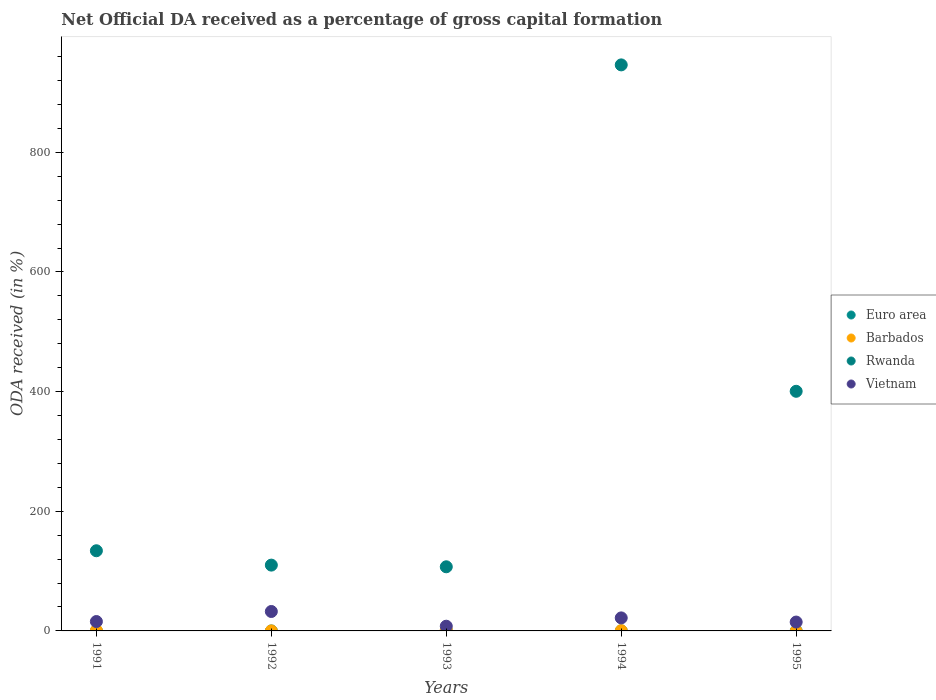Is the number of dotlines equal to the number of legend labels?
Provide a short and direct response. No. What is the net ODA received in Barbados in 1995?
Ensure brevity in your answer.  0. Across all years, what is the maximum net ODA received in Euro area?
Keep it short and to the point. 0.01. Across all years, what is the minimum net ODA received in Euro area?
Ensure brevity in your answer.  0. In which year was the net ODA received in Vietnam maximum?
Give a very brief answer. 1992. What is the total net ODA received in Rwanda in the graph?
Make the answer very short. 1697.77. What is the difference between the net ODA received in Euro area in 1994 and that in 1995?
Your response must be concise. 0. What is the difference between the net ODA received in Vietnam in 1991 and the net ODA received in Rwanda in 1992?
Provide a short and direct response. -94.31. What is the average net ODA received in Euro area per year?
Your answer should be very brief. 0. In the year 1995, what is the difference between the net ODA received in Rwanda and net ODA received in Euro area?
Your answer should be compact. 400.51. What is the ratio of the net ODA received in Rwanda in 1993 to that in 1995?
Provide a succinct answer. 0.27. Is the net ODA received in Rwanda in 1991 less than that in 1993?
Offer a very short reply. No. What is the difference between the highest and the second highest net ODA received in Euro area?
Offer a terse response. 0. What is the difference between the highest and the lowest net ODA received in Rwanda?
Ensure brevity in your answer.  838.89. In how many years, is the net ODA received in Vietnam greater than the average net ODA received in Vietnam taken over all years?
Your answer should be very brief. 2. Is the sum of the net ODA received in Rwanda in 1993 and 1994 greater than the maximum net ODA received in Euro area across all years?
Your response must be concise. Yes. Is it the case that in every year, the sum of the net ODA received in Euro area and net ODA received in Barbados  is greater than the sum of net ODA received in Vietnam and net ODA received in Rwanda?
Keep it short and to the point. No. Is it the case that in every year, the sum of the net ODA received in Vietnam and net ODA received in Euro area  is greater than the net ODA received in Rwanda?
Your answer should be compact. No. Is the net ODA received in Euro area strictly greater than the net ODA received in Barbados over the years?
Make the answer very short. No. Is the net ODA received in Vietnam strictly less than the net ODA received in Euro area over the years?
Give a very brief answer. No. How many dotlines are there?
Your response must be concise. 4. How many years are there in the graph?
Ensure brevity in your answer.  5. Are the values on the major ticks of Y-axis written in scientific E-notation?
Give a very brief answer. No. Does the graph contain grids?
Ensure brevity in your answer.  No. How many legend labels are there?
Offer a terse response. 4. How are the legend labels stacked?
Your answer should be very brief. Vertical. What is the title of the graph?
Keep it short and to the point. Net Official DA received as a percentage of gross capital formation. Does "Madagascar" appear as one of the legend labels in the graph?
Offer a very short reply. No. What is the label or title of the Y-axis?
Your response must be concise. ODA received (in %). What is the ODA received (in %) of Euro area in 1991?
Offer a terse response. 0. What is the ODA received (in %) in Barbados in 1991?
Give a very brief answer. 0.77. What is the ODA received (in %) of Rwanda in 1991?
Offer a terse response. 134. What is the ODA received (in %) in Vietnam in 1991?
Make the answer very short. 15.69. What is the ODA received (in %) in Euro area in 1992?
Offer a terse response. 0. What is the ODA received (in %) of Barbados in 1992?
Your answer should be compact. 0.02. What is the ODA received (in %) of Rwanda in 1992?
Keep it short and to the point. 110. What is the ODA received (in %) in Vietnam in 1992?
Provide a short and direct response. 32.47. What is the ODA received (in %) in Euro area in 1993?
Make the answer very short. 0.01. What is the ODA received (in %) of Barbados in 1993?
Keep it short and to the point. 1.81. What is the ODA received (in %) in Rwanda in 1993?
Provide a short and direct response. 107.19. What is the ODA received (in %) in Vietnam in 1993?
Offer a very short reply. 7.87. What is the ODA received (in %) in Euro area in 1994?
Keep it short and to the point. 0.01. What is the ODA received (in %) of Barbados in 1994?
Give a very brief answer. 0.43. What is the ODA received (in %) in Rwanda in 1994?
Keep it short and to the point. 946.08. What is the ODA received (in %) of Vietnam in 1994?
Your answer should be very brief. 21.77. What is the ODA received (in %) in Euro area in 1995?
Make the answer very short. 0.01. What is the ODA received (in %) in Barbados in 1995?
Your response must be concise. 0. What is the ODA received (in %) in Rwanda in 1995?
Offer a terse response. 400.51. What is the ODA received (in %) of Vietnam in 1995?
Provide a short and direct response. 14.83. Across all years, what is the maximum ODA received (in %) of Euro area?
Provide a short and direct response. 0.01. Across all years, what is the maximum ODA received (in %) in Barbados?
Offer a terse response. 1.81. Across all years, what is the maximum ODA received (in %) in Rwanda?
Your answer should be compact. 946.08. Across all years, what is the maximum ODA received (in %) in Vietnam?
Offer a very short reply. 32.47. Across all years, what is the minimum ODA received (in %) of Euro area?
Ensure brevity in your answer.  0. Across all years, what is the minimum ODA received (in %) of Rwanda?
Your answer should be very brief. 107.19. Across all years, what is the minimum ODA received (in %) of Vietnam?
Make the answer very short. 7.87. What is the total ODA received (in %) of Euro area in the graph?
Offer a terse response. 0.03. What is the total ODA received (in %) of Barbados in the graph?
Ensure brevity in your answer.  3.04. What is the total ODA received (in %) in Rwanda in the graph?
Provide a short and direct response. 1697.77. What is the total ODA received (in %) in Vietnam in the graph?
Keep it short and to the point. 92.64. What is the difference between the ODA received (in %) of Euro area in 1991 and that in 1992?
Provide a succinct answer. 0. What is the difference between the ODA received (in %) of Barbados in 1991 and that in 1992?
Ensure brevity in your answer.  0.75. What is the difference between the ODA received (in %) of Rwanda in 1991 and that in 1992?
Your response must be concise. 24. What is the difference between the ODA received (in %) in Vietnam in 1991 and that in 1992?
Give a very brief answer. -16.78. What is the difference between the ODA received (in %) of Euro area in 1991 and that in 1993?
Offer a terse response. -0. What is the difference between the ODA received (in %) of Barbados in 1991 and that in 1993?
Ensure brevity in your answer.  -1.04. What is the difference between the ODA received (in %) of Rwanda in 1991 and that in 1993?
Ensure brevity in your answer.  26.81. What is the difference between the ODA received (in %) of Vietnam in 1991 and that in 1993?
Your answer should be compact. 7.82. What is the difference between the ODA received (in %) in Euro area in 1991 and that in 1994?
Your answer should be very brief. -0. What is the difference between the ODA received (in %) of Barbados in 1991 and that in 1994?
Offer a terse response. 0.34. What is the difference between the ODA received (in %) of Rwanda in 1991 and that in 1994?
Keep it short and to the point. -812.08. What is the difference between the ODA received (in %) in Vietnam in 1991 and that in 1994?
Your answer should be compact. -6.08. What is the difference between the ODA received (in %) of Euro area in 1991 and that in 1995?
Provide a succinct answer. -0. What is the difference between the ODA received (in %) of Rwanda in 1991 and that in 1995?
Provide a succinct answer. -266.52. What is the difference between the ODA received (in %) in Vietnam in 1991 and that in 1995?
Give a very brief answer. 0.86. What is the difference between the ODA received (in %) of Euro area in 1992 and that in 1993?
Ensure brevity in your answer.  -0. What is the difference between the ODA received (in %) in Barbados in 1992 and that in 1993?
Keep it short and to the point. -1.79. What is the difference between the ODA received (in %) of Rwanda in 1992 and that in 1993?
Ensure brevity in your answer.  2.81. What is the difference between the ODA received (in %) in Vietnam in 1992 and that in 1993?
Your answer should be very brief. 24.6. What is the difference between the ODA received (in %) of Euro area in 1992 and that in 1994?
Offer a very short reply. -0.01. What is the difference between the ODA received (in %) of Barbados in 1992 and that in 1994?
Ensure brevity in your answer.  -0.41. What is the difference between the ODA received (in %) in Rwanda in 1992 and that in 1994?
Keep it short and to the point. -836.08. What is the difference between the ODA received (in %) in Vietnam in 1992 and that in 1994?
Your answer should be compact. 10.7. What is the difference between the ODA received (in %) of Euro area in 1992 and that in 1995?
Your answer should be compact. -0. What is the difference between the ODA received (in %) of Rwanda in 1992 and that in 1995?
Your response must be concise. -290.52. What is the difference between the ODA received (in %) in Vietnam in 1992 and that in 1995?
Provide a succinct answer. 17.64. What is the difference between the ODA received (in %) of Euro area in 1993 and that in 1994?
Keep it short and to the point. -0. What is the difference between the ODA received (in %) in Barbados in 1993 and that in 1994?
Your answer should be compact. 1.39. What is the difference between the ODA received (in %) of Rwanda in 1993 and that in 1994?
Provide a succinct answer. -838.89. What is the difference between the ODA received (in %) of Vietnam in 1993 and that in 1994?
Your answer should be very brief. -13.9. What is the difference between the ODA received (in %) of Rwanda in 1993 and that in 1995?
Provide a succinct answer. -293.32. What is the difference between the ODA received (in %) in Vietnam in 1993 and that in 1995?
Make the answer very short. -6.96. What is the difference between the ODA received (in %) in Euro area in 1994 and that in 1995?
Your response must be concise. 0. What is the difference between the ODA received (in %) of Rwanda in 1994 and that in 1995?
Give a very brief answer. 545.56. What is the difference between the ODA received (in %) of Vietnam in 1994 and that in 1995?
Ensure brevity in your answer.  6.94. What is the difference between the ODA received (in %) of Euro area in 1991 and the ODA received (in %) of Barbados in 1992?
Ensure brevity in your answer.  -0.02. What is the difference between the ODA received (in %) of Euro area in 1991 and the ODA received (in %) of Rwanda in 1992?
Offer a terse response. -109.99. What is the difference between the ODA received (in %) in Euro area in 1991 and the ODA received (in %) in Vietnam in 1992?
Provide a short and direct response. -32.47. What is the difference between the ODA received (in %) of Barbados in 1991 and the ODA received (in %) of Rwanda in 1992?
Give a very brief answer. -109.22. What is the difference between the ODA received (in %) of Barbados in 1991 and the ODA received (in %) of Vietnam in 1992?
Make the answer very short. -31.7. What is the difference between the ODA received (in %) in Rwanda in 1991 and the ODA received (in %) in Vietnam in 1992?
Offer a very short reply. 101.52. What is the difference between the ODA received (in %) in Euro area in 1991 and the ODA received (in %) in Barbados in 1993?
Offer a terse response. -1.81. What is the difference between the ODA received (in %) of Euro area in 1991 and the ODA received (in %) of Rwanda in 1993?
Provide a succinct answer. -107.19. What is the difference between the ODA received (in %) in Euro area in 1991 and the ODA received (in %) in Vietnam in 1993?
Provide a short and direct response. -7.87. What is the difference between the ODA received (in %) of Barbados in 1991 and the ODA received (in %) of Rwanda in 1993?
Your answer should be compact. -106.42. What is the difference between the ODA received (in %) of Barbados in 1991 and the ODA received (in %) of Vietnam in 1993?
Give a very brief answer. -7.1. What is the difference between the ODA received (in %) in Rwanda in 1991 and the ODA received (in %) in Vietnam in 1993?
Provide a succinct answer. 126.12. What is the difference between the ODA received (in %) of Euro area in 1991 and the ODA received (in %) of Barbados in 1994?
Give a very brief answer. -0.42. What is the difference between the ODA received (in %) in Euro area in 1991 and the ODA received (in %) in Rwanda in 1994?
Offer a very short reply. -946.07. What is the difference between the ODA received (in %) in Euro area in 1991 and the ODA received (in %) in Vietnam in 1994?
Offer a very short reply. -21.77. What is the difference between the ODA received (in %) in Barbados in 1991 and the ODA received (in %) in Rwanda in 1994?
Your response must be concise. -945.3. What is the difference between the ODA received (in %) of Barbados in 1991 and the ODA received (in %) of Vietnam in 1994?
Provide a succinct answer. -21. What is the difference between the ODA received (in %) of Rwanda in 1991 and the ODA received (in %) of Vietnam in 1994?
Your response must be concise. 112.22. What is the difference between the ODA received (in %) in Euro area in 1991 and the ODA received (in %) in Rwanda in 1995?
Make the answer very short. -400.51. What is the difference between the ODA received (in %) in Euro area in 1991 and the ODA received (in %) in Vietnam in 1995?
Provide a short and direct response. -14.83. What is the difference between the ODA received (in %) in Barbados in 1991 and the ODA received (in %) in Rwanda in 1995?
Keep it short and to the point. -399.74. What is the difference between the ODA received (in %) of Barbados in 1991 and the ODA received (in %) of Vietnam in 1995?
Your answer should be very brief. -14.06. What is the difference between the ODA received (in %) of Rwanda in 1991 and the ODA received (in %) of Vietnam in 1995?
Your answer should be compact. 119.16. What is the difference between the ODA received (in %) in Euro area in 1992 and the ODA received (in %) in Barbados in 1993?
Ensure brevity in your answer.  -1.81. What is the difference between the ODA received (in %) in Euro area in 1992 and the ODA received (in %) in Rwanda in 1993?
Make the answer very short. -107.19. What is the difference between the ODA received (in %) in Euro area in 1992 and the ODA received (in %) in Vietnam in 1993?
Your answer should be compact. -7.87. What is the difference between the ODA received (in %) in Barbados in 1992 and the ODA received (in %) in Rwanda in 1993?
Your answer should be very brief. -107.17. What is the difference between the ODA received (in %) of Barbados in 1992 and the ODA received (in %) of Vietnam in 1993?
Provide a short and direct response. -7.85. What is the difference between the ODA received (in %) of Rwanda in 1992 and the ODA received (in %) of Vietnam in 1993?
Provide a short and direct response. 102.13. What is the difference between the ODA received (in %) of Euro area in 1992 and the ODA received (in %) of Barbados in 1994?
Give a very brief answer. -0.43. What is the difference between the ODA received (in %) of Euro area in 1992 and the ODA received (in %) of Rwanda in 1994?
Your answer should be compact. -946.07. What is the difference between the ODA received (in %) in Euro area in 1992 and the ODA received (in %) in Vietnam in 1994?
Make the answer very short. -21.77. What is the difference between the ODA received (in %) of Barbados in 1992 and the ODA received (in %) of Rwanda in 1994?
Make the answer very short. -946.05. What is the difference between the ODA received (in %) in Barbados in 1992 and the ODA received (in %) in Vietnam in 1994?
Make the answer very short. -21.75. What is the difference between the ODA received (in %) in Rwanda in 1992 and the ODA received (in %) in Vietnam in 1994?
Your answer should be compact. 88.23. What is the difference between the ODA received (in %) of Euro area in 1992 and the ODA received (in %) of Rwanda in 1995?
Give a very brief answer. -400.51. What is the difference between the ODA received (in %) in Euro area in 1992 and the ODA received (in %) in Vietnam in 1995?
Give a very brief answer. -14.83. What is the difference between the ODA received (in %) in Barbados in 1992 and the ODA received (in %) in Rwanda in 1995?
Provide a short and direct response. -400.49. What is the difference between the ODA received (in %) in Barbados in 1992 and the ODA received (in %) in Vietnam in 1995?
Your answer should be compact. -14.81. What is the difference between the ODA received (in %) of Rwanda in 1992 and the ODA received (in %) of Vietnam in 1995?
Your answer should be very brief. 95.17. What is the difference between the ODA received (in %) in Euro area in 1993 and the ODA received (in %) in Barbados in 1994?
Offer a terse response. -0.42. What is the difference between the ODA received (in %) in Euro area in 1993 and the ODA received (in %) in Rwanda in 1994?
Give a very brief answer. -946.07. What is the difference between the ODA received (in %) of Euro area in 1993 and the ODA received (in %) of Vietnam in 1994?
Offer a terse response. -21.77. What is the difference between the ODA received (in %) in Barbados in 1993 and the ODA received (in %) in Rwanda in 1994?
Offer a terse response. -944.26. What is the difference between the ODA received (in %) of Barbados in 1993 and the ODA received (in %) of Vietnam in 1994?
Offer a very short reply. -19.96. What is the difference between the ODA received (in %) in Rwanda in 1993 and the ODA received (in %) in Vietnam in 1994?
Make the answer very short. 85.42. What is the difference between the ODA received (in %) in Euro area in 1993 and the ODA received (in %) in Rwanda in 1995?
Your answer should be very brief. -400.51. What is the difference between the ODA received (in %) of Euro area in 1993 and the ODA received (in %) of Vietnam in 1995?
Your answer should be compact. -14.83. What is the difference between the ODA received (in %) in Barbados in 1993 and the ODA received (in %) in Rwanda in 1995?
Offer a very short reply. -398.7. What is the difference between the ODA received (in %) of Barbados in 1993 and the ODA received (in %) of Vietnam in 1995?
Provide a succinct answer. -13.02. What is the difference between the ODA received (in %) in Rwanda in 1993 and the ODA received (in %) in Vietnam in 1995?
Give a very brief answer. 92.36. What is the difference between the ODA received (in %) of Euro area in 1994 and the ODA received (in %) of Rwanda in 1995?
Your answer should be compact. -400.51. What is the difference between the ODA received (in %) of Euro area in 1994 and the ODA received (in %) of Vietnam in 1995?
Your answer should be compact. -14.82. What is the difference between the ODA received (in %) of Barbados in 1994 and the ODA received (in %) of Rwanda in 1995?
Your answer should be compact. -400.09. What is the difference between the ODA received (in %) of Barbados in 1994 and the ODA received (in %) of Vietnam in 1995?
Your answer should be very brief. -14.4. What is the difference between the ODA received (in %) of Rwanda in 1994 and the ODA received (in %) of Vietnam in 1995?
Provide a succinct answer. 931.24. What is the average ODA received (in %) in Euro area per year?
Make the answer very short. 0.01. What is the average ODA received (in %) of Barbados per year?
Your response must be concise. 0.61. What is the average ODA received (in %) in Rwanda per year?
Provide a short and direct response. 339.55. What is the average ODA received (in %) of Vietnam per year?
Your response must be concise. 18.53. In the year 1991, what is the difference between the ODA received (in %) of Euro area and ODA received (in %) of Barbados?
Make the answer very short. -0.77. In the year 1991, what is the difference between the ODA received (in %) of Euro area and ODA received (in %) of Rwanda?
Ensure brevity in your answer.  -133.99. In the year 1991, what is the difference between the ODA received (in %) in Euro area and ODA received (in %) in Vietnam?
Provide a short and direct response. -15.69. In the year 1991, what is the difference between the ODA received (in %) of Barbados and ODA received (in %) of Rwanda?
Provide a short and direct response. -133.22. In the year 1991, what is the difference between the ODA received (in %) of Barbados and ODA received (in %) of Vietnam?
Your answer should be very brief. -14.92. In the year 1991, what is the difference between the ODA received (in %) of Rwanda and ODA received (in %) of Vietnam?
Make the answer very short. 118.31. In the year 1992, what is the difference between the ODA received (in %) in Euro area and ODA received (in %) in Barbados?
Ensure brevity in your answer.  -0.02. In the year 1992, what is the difference between the ODA received (in %) of Euro area and ODA received (in %) of Rwanda?
Offer a very short reply. -109.99. In the year 1992, what is the difference between the ODA received (in %) of Euro area and ODA received (in %) of Vietnam?
Offer a very short reply. -32.47. In the year 1992, what is the difference between the ODA received (in %) in Barbados and ODA received (in %) in Rwanda?
Provide a short and direct response. -109.97. In the year 1992, what is the difference between the ODA received (in %) in Barbados and ODA received (in %) in Vietnam?
Provide a succinct answer. -32.45. In the year 1992, what is the difference between the ODA received (in %) of Rwanda and ODA received (in %) of Vietnam?
Provide a short and direct response. 77.52. In the year 1993, what is the difference between the ODA received (in %) in Euro area and ODA received (in %) in Barbados?
Ensure brevity in your answer.  -1.81. In the year 1993, what is the difference between the ODA received (in %) in Euro area and ODA received (in %) in Rwanda?
Provide a short and direct response. -107.18. In the year 1993, what is the difference between the ODA received (in %) in Euro area and ODA received (in %) in Vietnam?
Offer a terse response. -7.86. In the year 1993, what is the difference between the ODA received (in %) of Barbados and ODA received (in %) of Rwanda?
Offer a terse response. -105.37. In the year 1993, what is the difference between the ODA received (in %) of Barbados and ODA received (in %) of Vietnam?
Offer a very short reply. -6.06. In the year 1993, what is the difference between the ODA received (in %) in Rwanda and ODA received (in %) in Vietnam?
Your answer should be compact. 99.32. In the year 1994, what is the difference between the ODA received (in %) of Euro area and ODA received (in %) of Barbados?
Your answer should be compact. -0.42. In the year 1994, what is the difference between the ODA received (in %) in Euro area and ODA received (in %) in Rwanda?
Make the answer very short. -946.07. In the year 1994, what is the difference between the ODA received (in %) of Euro area and ODA received (in %) of Vietnam?
Make the answer very short. -21.76. In the year 1994, what is the difference between the ODA received (in %) of Barbados and ODA received (in %) of Rwanda?
Your response must be concise. -945.65. In the year 1994, what is the difference between the ODA received (in %) in Barbados and ODA received (in %) in Vietnam?
Your answer should be very brief. -21.34. In the year 1994, what is the difference between the ODA received (in %) in Rwanda and ODA received (in %) in Vietnam?
Provide a succinct answer. 924.3. In the year 1995, what is the difference between the ODA received (in %) of Euro area and ODA received (in %) of Rwanda?
Your response must be concise. -400.51. In the year 1995, what is the difference between the ODA received (in %) of Euro area and ODA received (in %) of Vietnam?
Your answer should be compact. -14.83. In the year 1995, what is the difference between the ODA received (in %) in Rwanda and ODA received (in %) in Vietnam?
Keep it short and to the point. 385.68. What is the ratio of the ODA received (in %) of Euro area in 1991 to that in 1992?
Give a very brief answer. 2.11. What is the ratio of the ODA received (in %) of Barbados in 1991 to that in 1992?
Your answer should be compact. 36.43. What is the ratio of the ODA received (in %) in Rwanda in 1991 to that in 1992?
Provide a short and direct response. 1.22. What is the ratio of the ODA received (in %) of Vietnam in 1991 to that in 1992?
Ensure brevity in your answer.  0.48. What is the ratio of the ODA received (in %) of Euro area in 1991 to that in 1993?
Provide a succinct answer. 0.77. What is the ratio of the ODA received (in %) of Barbados in 1991 to that in 1993?
Your response must be concise. 0.43. What is the ratio of the ODA received (in %) in Rwanda in 1991 to that in 1993?
Ensure brevity in your answer.  1.25. What is the ratio of the ODA received (in %) in Vietnam in 1991 to that in 1993?
Your answer should be very brief. 1.99. What is the ratio of the ODA received (in %) of Euro area in 1991 to that in 1994?
Your response must be concise. 0.5. What is the ratio of the ODA received (in %) of Barbados in 1991 to that in 1994?
Your response must be concise. 1.8. What is the ratio of the ODA received (in %) in Rwanda in 1991 to that in 1994?
Keep it short and to the point. 0.14. What is the ratio of the ODA received (in %) in Vietnam in 1991 to that in 1994?
Keep it short and to the point. 0.72. What is the ratio of the ODA received (in %) in Euro area in 1991 to that in 1995?
Make the answer very short. 0.83. What is the ratio of the ODA received (in %) in Rwanda in 1991 to that in 1995?
Keep it short and to the point. 0.33. What is the ratio of the ODA received (in %) of Vietnam in 1991 to that in 1995?
Your answer should be very brief. 1.06. What is the ratio of the ODA received (in %) of Euro area in 1992 to that in 1993?
Give a very brief answer. 0.36. What is the ratio of the ODA received (in %) of Barbados in 1992 to that in 1993?
Your answer should be compact. 0.01. What is the ratio of the ODA received (in %) in Rwanda in 1992 to that in 1993?
Your answer should be compact. 1.03. What is the ratio of the ODA received (in %) of Vietnam in 1992 to that in 1993?
Offer a terse response. 4.13. What is the ratio of the ODA received (in %) of Euro area in 1992 to that in 1994?
Your answer should be very brief. 0.24. What is the ratio of the ODA received (in %) in Barbados in 1992 to that in 1994?
Your response must be concise. 0.05. What is the ratio of the ODA received (in %) in Rwanda in 1992 to that in 1994?
Offer a very short reply. 0.12. What is the ratio of the ODA received (in %) in Vietnam in 1992 to that in 1994?
Ensure brevity in your answer.  1.49. What is the ratio of the ODA received (in %) in Euro area in 1992 to that in 1995?
Keep it short and to the point. 0.39. What is the ratio of the ODA received (in %) of Rwanda in 1992 to that in 1995?
Provide a short and direct response. 0.27. What is the ratio of the ODA received (in %) of Vietnam in 1992 to that in 1995?
Your answer should be very brief. 2.19. What is the ratio of the ODA received (in %) of Euro area in 1993 to that in 1994?
Keep it short and to the point. 0.65. What is the ratio of the ODA received (in %) in Barbados in 1993 to that in 1994?
Give a very brief answer. 4.24. What is the ratio of the ODA received (in %) in Rwanda in 1993 to that in 1994?
Make the answer very short. 0.11. What is the ratio of the ODA received (in %) of Vietnam in 1993 to that in 1994?
Your answer should be compact. 0.36. What is the ratio of the ODA received (in %) in Euro area in 1993 to that in 1995?
Offer a terse response. 1.09. What is the ratio of the ODA received (in %) in Rwanda in 1993 to that in 1995?
Offer a terse response. 0.27. What is the ratio of the ODA received (in %) in Vietnam in 1993 to that in 1995?
Give a very brief answer. 0.53. What is the ratio of the ODA received (in %) in Euro area in 1994 to that in 1995?
Make the answer very short. 1.67. What is the ratio of the ODA received (in %) of Rwanda in 1994 to that in 1995?
Keep it short and to the point. 2.36. What is the ratio of the ODA received (in %) in Vietnam in 1994 to that in 1995?
Your answer should be very brief. 1.47. What is the difference between the highest and the second highest ODA received (in %) in Euro area?
Your response must be concise. 0. What is the difference between the highest and the second highest ODA received (in %) of Barbados?
Your answer should be very brief. 1.04. What is the difference between the highest and the second highest ODA received (in %) in Rwanda?
Offer a terse response. 545.56. What is the difference between the highest and the second highest ODA received (in %) in Vietnam?
Your answer should be very brief. 10.7. What is the difference between the highest and the lowest ODA received (in %) of Euro area?
Offer a very short reply. 0.01. What is the difference between the highest and the lowest ODA received (in %) in Barbados?
Your answer should be compact. 1.81. What is the difference between the highest and the lowest ODA received (in %) in Rwanda?
Your response must be concise. 838.89. What is the difference between the highest and the lowest ODA received (in %) of Vietnam?
Your response must be concise. 24.6. 